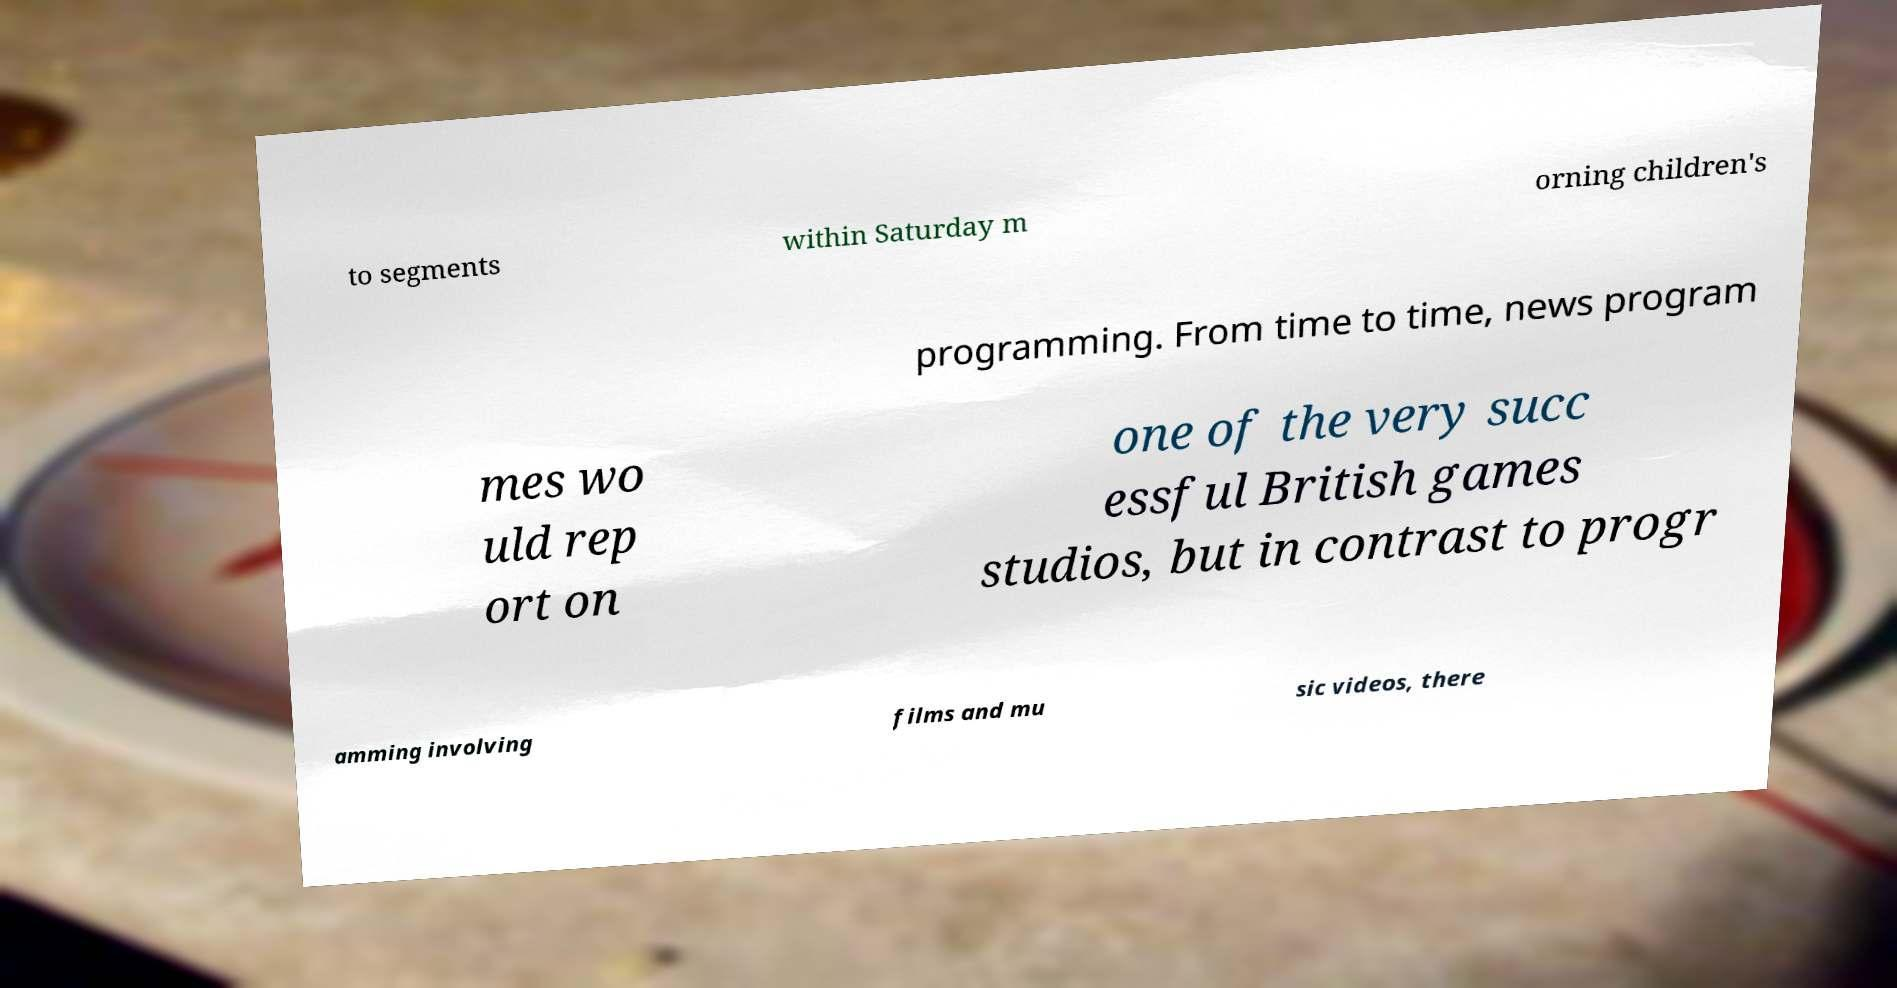Can you read and provide the text displayed in the image?This photo seems to have some interesting text. Can you extract and type it out for me? to segments within Saturday m orning children's programming. From time to time, news program mes wo uld rep ort on one of the very succ essful British games studios, but in contrast to progr amming involving films and mu sic videos, there 